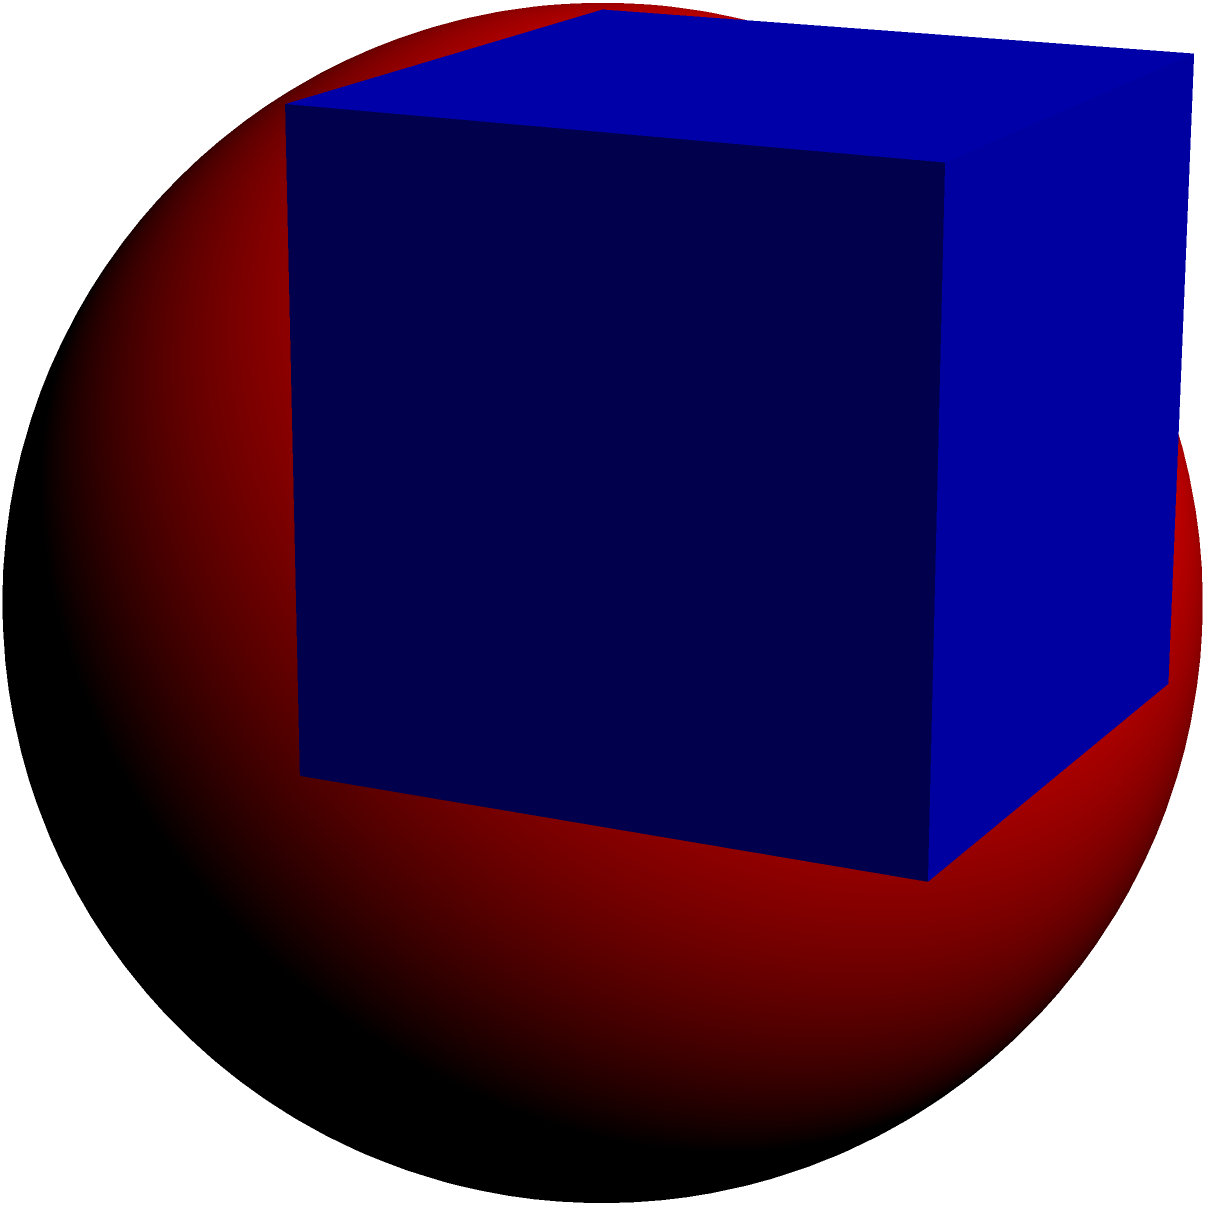As part of a university outreach program, you're tasked with creating an engaging mathematics display. You decide to showcase a sphere inscribed within a transparent cube. If the edge length of the cube is 10 cm, what is the volume of the inscribed sphere? Round your answer to the nearest cubic centimeter. Let's approach this step-by-step:

1) In a cube with an inscribed sphere, the diameter of the sphere is equal to the edge length of the cube. So, if the cube's edge is 10 cm, the sphere's diameter is also 10 cm.

2) The radius of the sphere is half of its diameter:
   $r = \frac{10}{2} = 5$ cm

3) The formula for the volume of a sphere is:
   $V = \frac{4}{3}\pi r^3$

4) Substituting our radius:
   $V = \frac{4}{3}\pi (5)^3$

5) Simplify:
   $V = \frac{4}{3}\pi (125)$
   $V = \frac{500}{3}\pi$

6) Calculate (use $\pi \approx 3.14159$):
   $V \approx 523.60$ cm³

7) Rounding to the nearest cubic centimeter:
   $V \approx 524$ cm³
Answer: 524 cm³ 